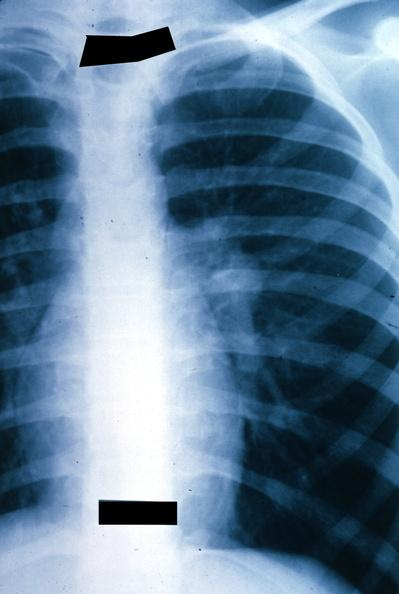what is present?
Answer the question using a single word or phrase. Metastatic malignant ependymoma 